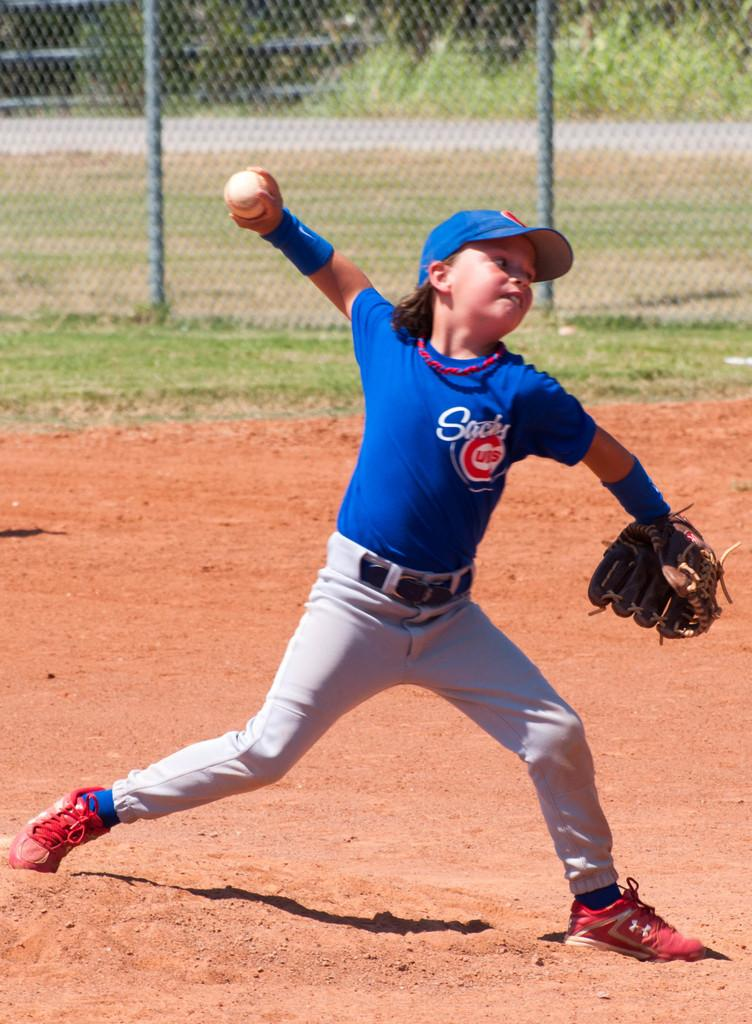<image>
Offer a succinct explanation of the picture presented. A young boy in a cubs baseball uniform gets ready to throw the ball. 